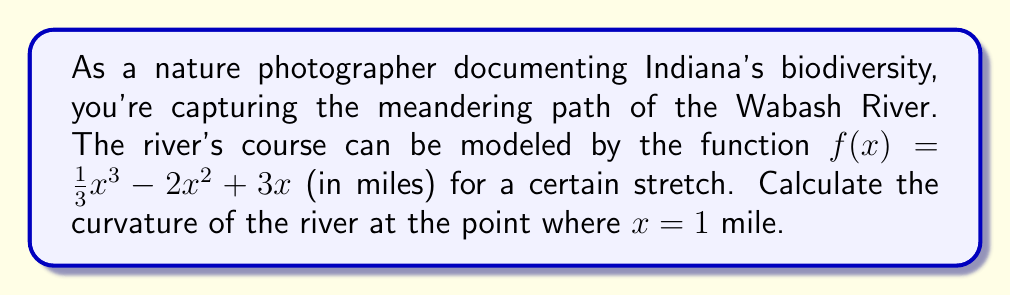What is the answer to this math problem? To find the curvature of the river at a specific point, we need to use the curvature formula:

$$\kappa = \frac{|f''(x)|}{(1 + [f'(x)]^2)^{3/2}}$$

Step 1: Find $f'(x)$
$$f'(x) = x^2 - 4x + 3$$

Step 2: Find $f''(x)$
$$f''(x) = 2x - 4$$

Step 3: Evaluate $f'(1)$ and $f''(1)$
$$f'(1) = 1^2 - 4(1) + 3 = 0$$
$$f''(1) = 2(1) - 4 = -2$$

Step 4: Substitute into the curvature formula
$$\kappa = \frac{|-2|}{(1 + [0]^2)^{3/2}} = \frac{2}{1^{3/2}} = 2$$

Therefore, the curvature of the river at $x = 1$ mile is 2 per mile.
Answer: 2 per mile 